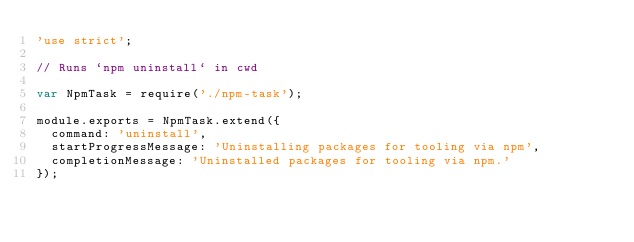<code> <loc_0><loc_0><loc_500><loc_500><_JavaScript_>'use strict';

// Runs `npm uninstall` in cwd

var NpmTask = require('./npm-task');

module.exports = NpmTask.extend({
  command: 'uninstall',
  startProgressMessage: 'Uninstalling packages for tooling via npm',
  completionMessage: 'Uninstalled packages for tooling via npm.'
});
</code> 